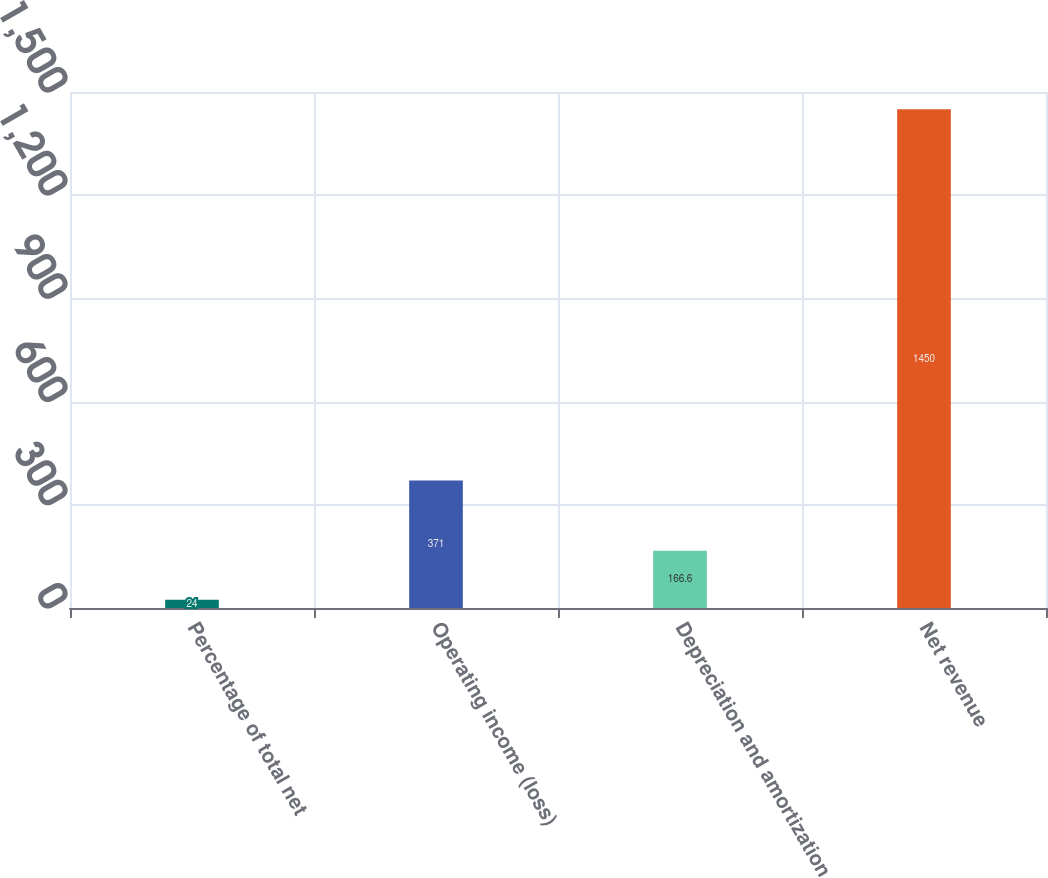Convert chart to OTSL. <chart><loc_0><loc_0><loc_500><loc_500><bar_chart><fcel>Percentage of total net<fcel>Operating income (loss)<fcel>Depreciation and amortization<fcel>Net revenue<nl><fcel>24<fcel>371<fcel>166.6<fcel>1450<nl></chart> 